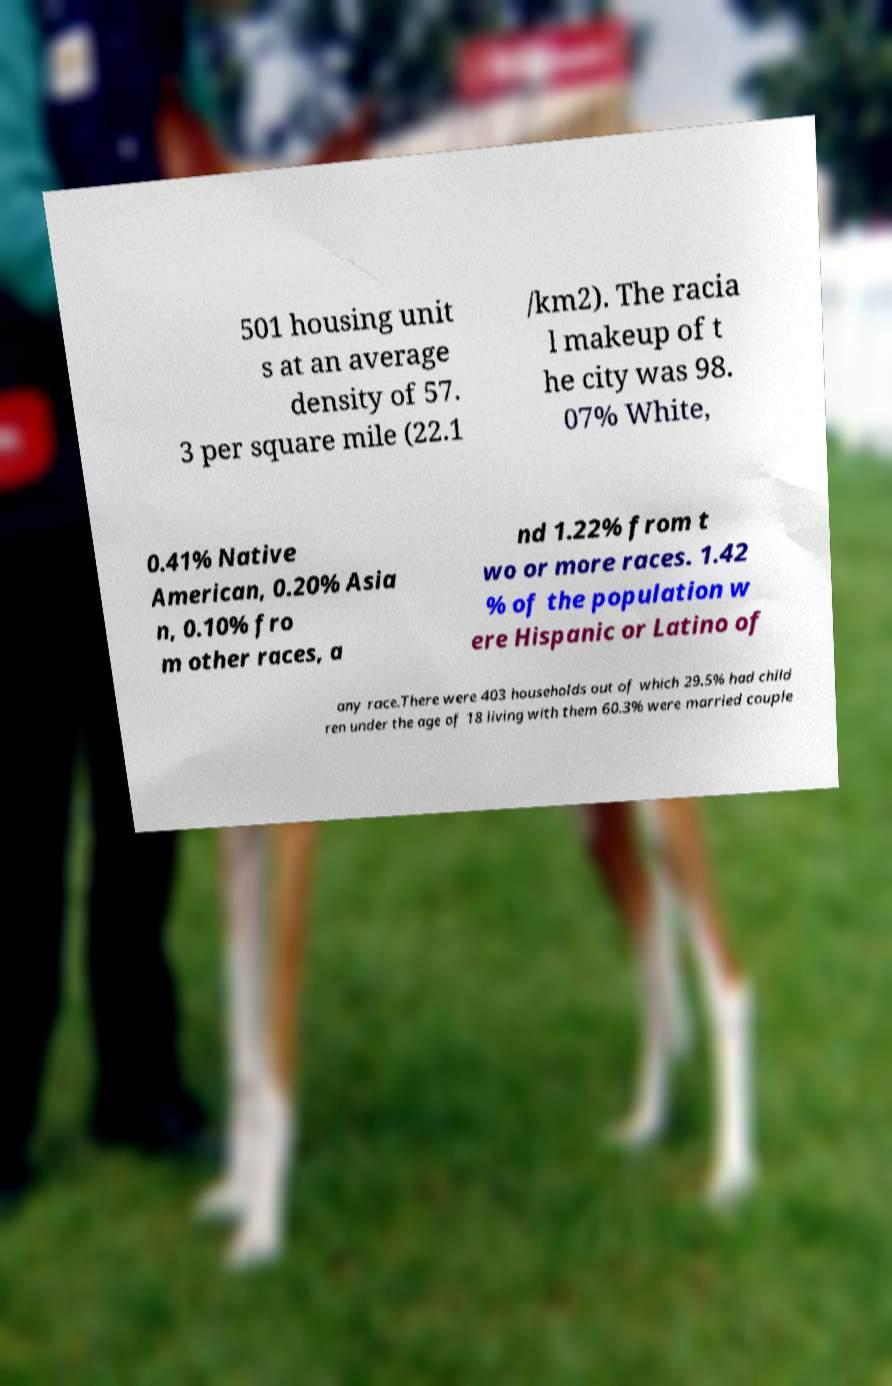Can you accurately transcribe the text from the provided image for me? 501 housing unit s at an average density of 57. 3 per square mile (22.1 /km2). The racia l makeup of t he city was 98. 07% White, 0.41% Native American, 0.20% Asia n, 0.10% fro m other races, a nd 1.22% from t wo or more races. 1.42 % of the population w ere Hispanic or Latino of any race.There were 403 households out of which 29.5% had child ren under the age of 18 living with them 60.3% were married couple 